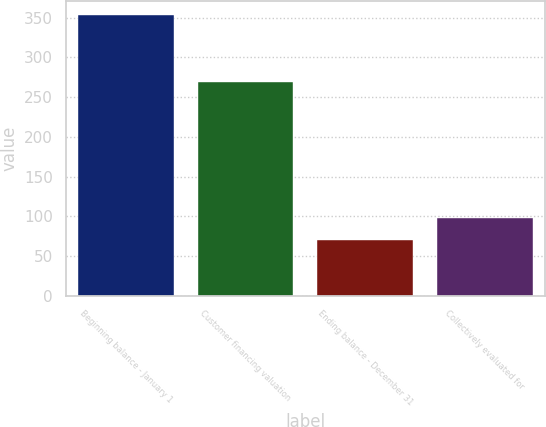Convert chart. <chart><loc_0><loc_0><loc_500><loc_500><bar_chart><fcel>Beginning balance - January 1<fcel>Customer financing valuation<fcel>Ending balance - December 31<fcel>Collectively evaluated for<nl><fcel>353<fcel>269<fcel>70<fcel>98.3<nl></chart> 